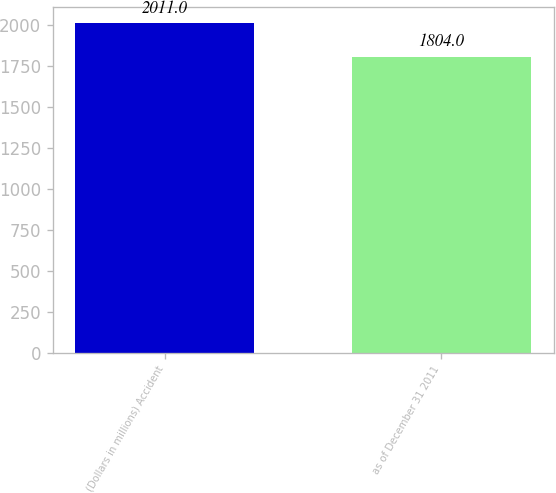Convert chart to OTSL. <chart><loc_0><loc_0><loc_500><loc_500><bar_chart><fcel>(Dollars in millions) Accident<fcel>as of December 31 2011<nl><fcel>2011<fcel>1804<nl></chart> 